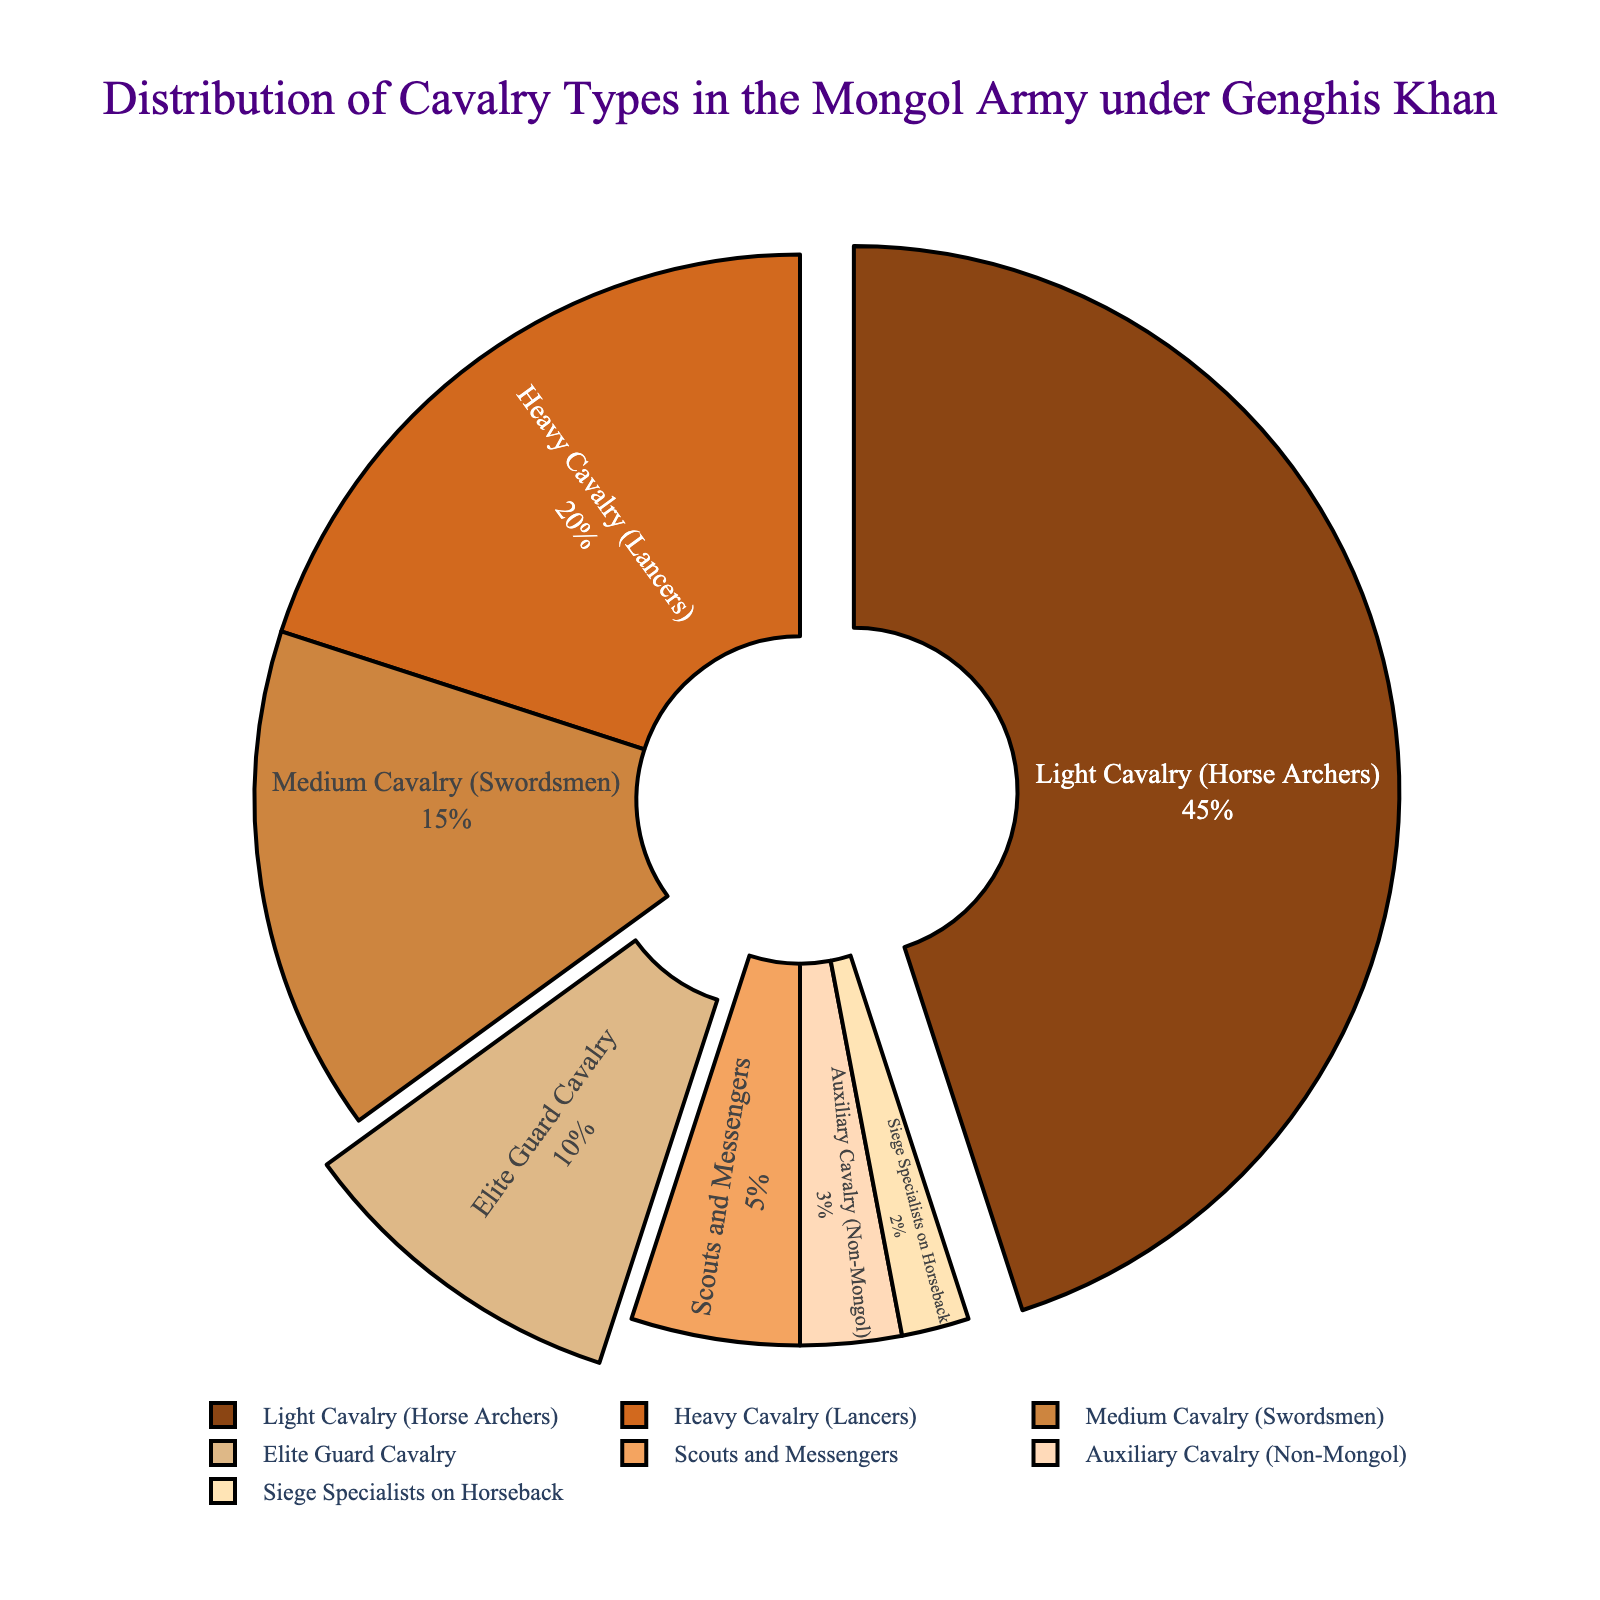What percentage of the Mongol army’s cavalry was made up of Light Cavalry (Horse Archers)? According to the pie chart, the percentage of Light Cavalry (Horse Archers) is shown next to its label.
Answer: 45% Which cavalry type comprises the smallest portion of the Mongol army under Genghis Khan? The segment representing the smallest portion in the pie chart corresponds to the Siege Specialists on Horseback.
Answer: Siege Specialists on Horseback What is the combined percentage of Light Cavalry (Horse Archers) and Heavy Cavalry (Lancers) in the Mongol army? Add the percentage of Light Cavalry (Horse Archers) and Heavy Cavalry (Lancers) from the chart: 45% + 20% = 65%.
Answer: 65% Compare the percentage of Medium Cavalry (Swordsmen) to Auxiliary Cavalry (Non-Mongol). Which is higher and by how much? Subtract the percentage of Auxiliary Cavalry (Non-Mongol) from the percentage of Medium Cavalry (Swordsmen): 15% - 3% = 12%. Medium Cavalry (Swordsmen) is higher by 12%.
Answer: Medium Cavalry (Swordsmen) by 12% How does the proportion of Elite Guard Cavalry compare to Scouts and Messengers? According to the chart, the Elite Guard Cavalry has a percentage of 10% while the Scouts and Messengers have 5%. Therefore, the Elite Guard Cavalry is double the percentage of Scouts and Messengers.
Answer: Elite Guard Cavalry is double What are the top three cavalry types by percentage composition in the Mongol army? The top three segments with the largest percentages are identified as Light Cavalry (Horse Archers), Heavy Cavalry (Lancers), and Medium Cavalry (Swordsmen) with values of 45%, 20%, and 15% respectively.
Answer: Light Cavalry (Horse Archers), Heavy Cavalry (Lancers), Medium Cavalry (Swordsmen) When combined, what total percentage of the cavalry does the Elite Guard Cavalry and Heavy Cavalry (Lancers) represent? Sum the percentage values of Elite Guard Cavalry and Heavy Cavalry (Lancers) shown in the chart: 10% + 20% = 30%.
Answer: 30% What is the visual distinction used for Elite Guard Cavalry and how does it compare to neighbouring categories? According to the pie chart, the segment for Elite Guard Cavalry may be slightly pulled out or highlighted compared to neighbouring categories for easy visual distinction.
Answer: Slightly pulled out Is the percentage of Light Cavalry (Horse Archers) greater than the combined percentage of Medium Cavalry (Swordsmen) and Heavy Cavalry (Lancers)? Add the percentages of Medium Cavalry (Swordsmen) and Heavy Cavalry (Lancers): 15% + 20% = 35%. Compare it to Light Cavalry (Horse Archers): 45% > 35%.
Answer: Yes 